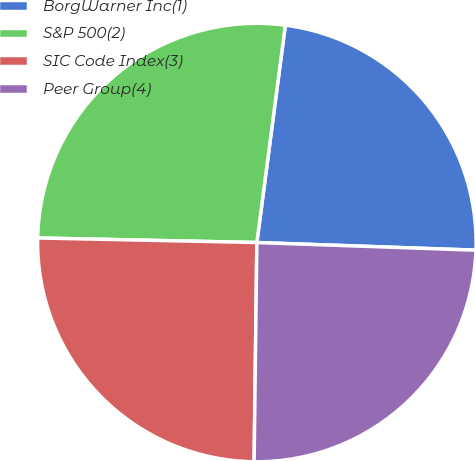Convert chart. <chart><loc_0><loc_0><loc_500><loc_500><pie_chart><fcel>BorgWarner Inc(1)<fcel>S&P 500(2)<fcel>SIC Code Index(3)<fcel>Peer Group(4)<nl><fcel>23.48%<fcel>26.74%<fcel>25.13%<fcel>24.64%<nl></chart> 